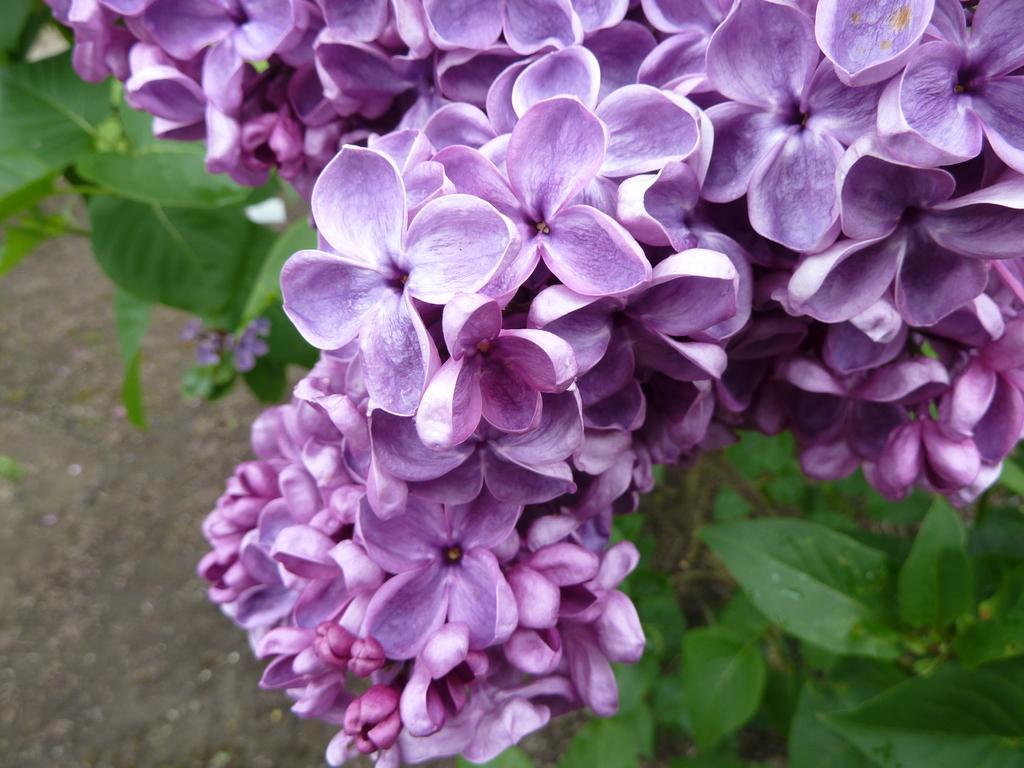Can you describe this image briefly? In this image there are purple flowers for a plant. 